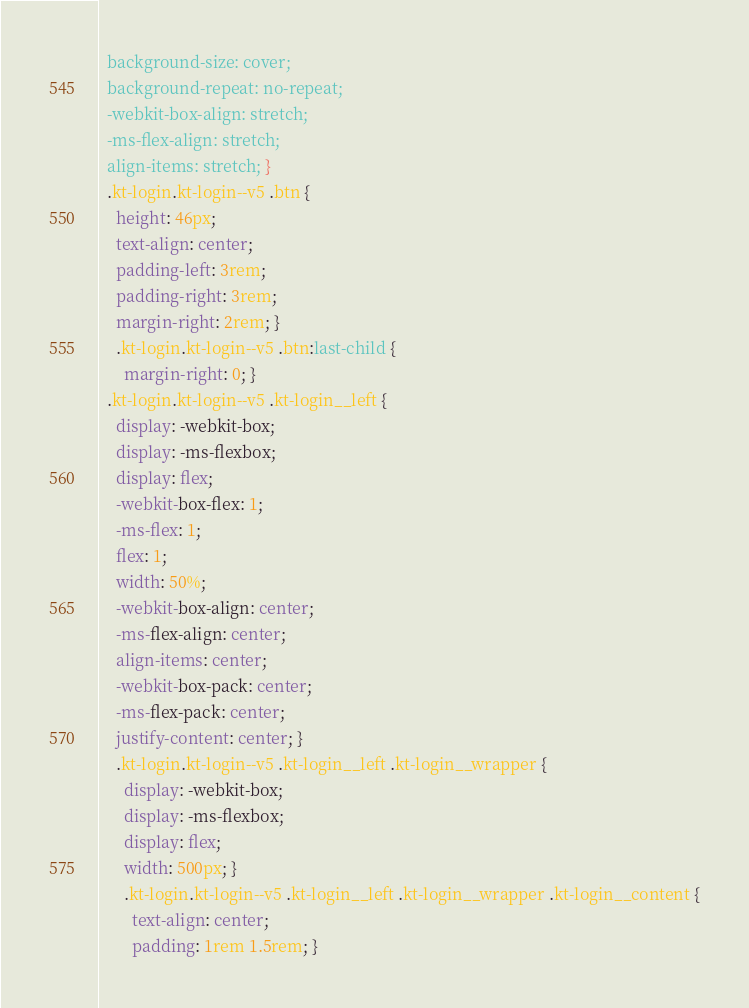<code> <loc_0><loc_0><loc_500><loc_500><_CSS_>  background-size: cover;
  background-repeat: no-repeat;
  -webkit-box-align: stretch;
  -ms-flex-align: stretch;
  align-items: stretch; }
  .kt-login.kt-login--v5 .btn {
    height: 46px;
    text-align: center;
    padding-left: 3rem;
    padding-right: 3rem;
    margin-right: 2rem; }
    .kt-login.kt-login--v5 .btn:last-child {
      margin-right: 0; }
  .kt-login.kt-login--v5 .kt-login__left {
    display: -webkit-box;
    display: -ms-flexbox;
    display: flex;
    -webkit-box-flex: 1;
    -ms-flex: 1;
    flex: 1;
    width: 50%;
    -webkit-box-align: center;
    -ms-flex-align: center;
    align-items: center;
    -webkit-box-pack: center;
    -ms-flex-pack: center;
    justify-content: center; }
    .kt-login.kt-login--v5 .kt-login__left .kt-login__wrapper {
      display: -webkit-box;
      display: -ms-flexbox;
      display: flex;
      width: 500px; }
      .kt-login.kt-login--v5 .kt-login__left .kt-login__wrapper .kt-login__content {
        text-align: center;
        padding: 1rem 1.5rem; }</code> 